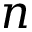Convert formula to latex. <formula><loc_0><loc_0><loc_500><loc_500>n</formula> 